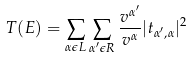<formula> <loc_0><loc_0><loc_500><loc_500>T ( E ) = \sum _ { \alpha \epsilon L } \sum _ { \alpha ^ { \prime } \epsilon R } \frac { v ^ { \alpha ^ { \prime } } } { v ^ { \alpha } } | t _ { \alpha ^ { \prime } , \alpha } | ^ { 2 }</formula> 